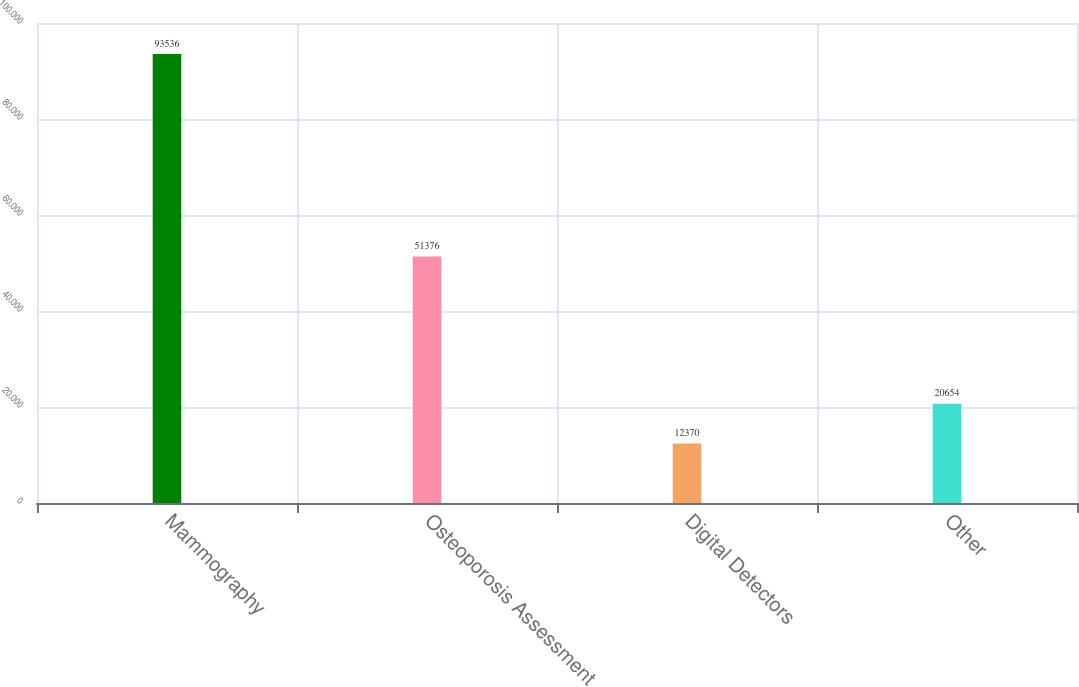Convert chart. <chart><loc_0><loc_0><loc_500><loc_500><bar_chart><fcel>Mammography<fcel>Osteoporosis Assessment<fcel>Digital Detectors<fcel>Other<nl><fcel>93536<fcel>51376<fcel>12370<fcel>20654<nl></chart> 